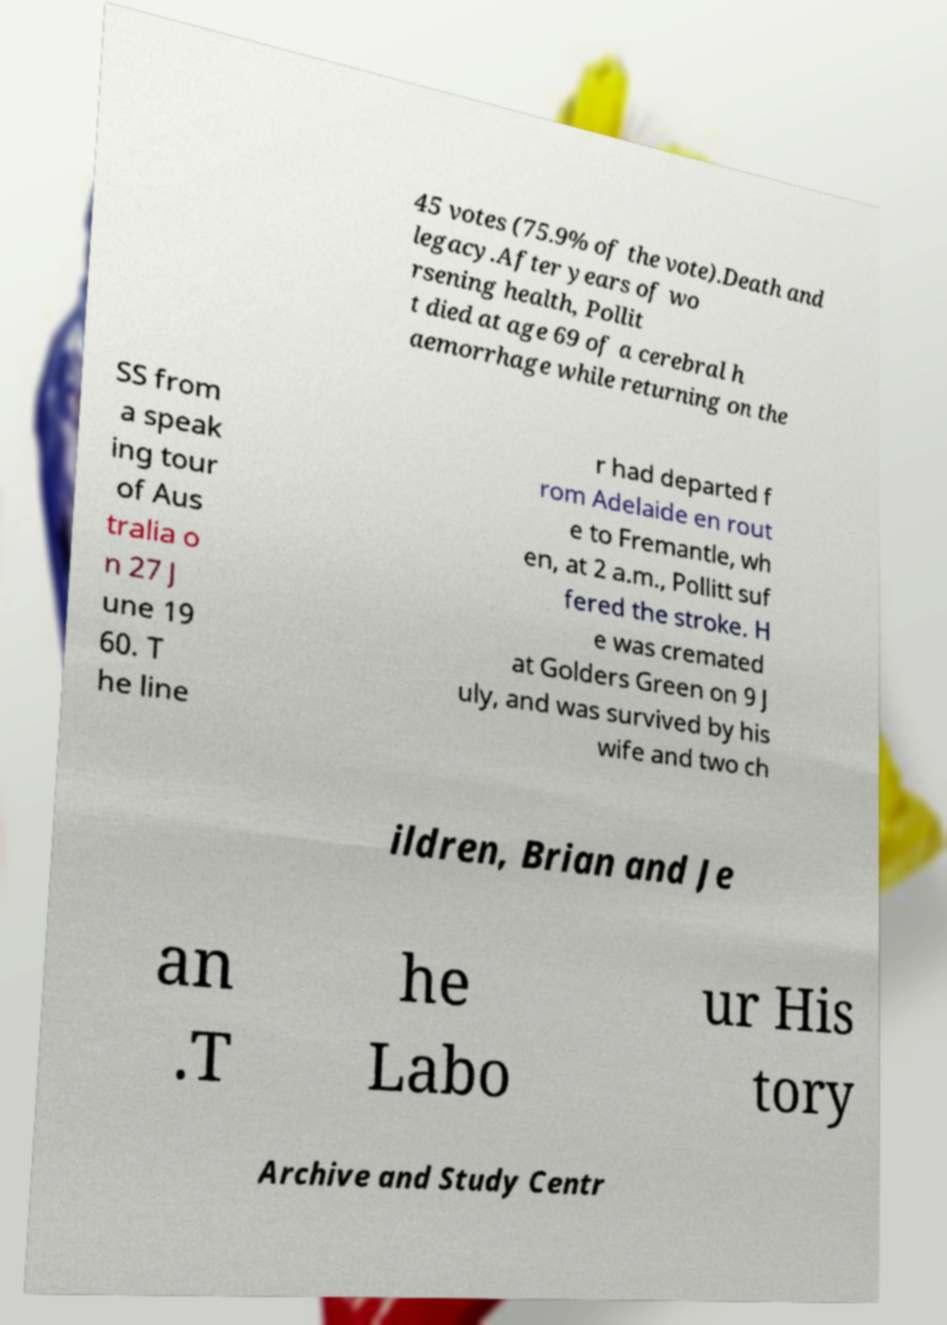Could you assist in decoding the text presented in this image and type it out clearly? 45 votes (75.9% of the vote).Death and legacy.After years of wo rsening health, Pollit t died at age 69 of a cerebral h aemorrhage while returning on the SS from a speak ing tour of Aus tralia o n 27 J une 19 60. T he line r had departed f rom Adelaide en rout e to Fremantle, wh en, at 2 a.m., Pollitt suf fered the stroke. H e was cremated at Golders Green on 9 J uly, and was survived by his wife and two ch ildren, Brian and Je an .T he Labo ur His tory Archive and Study Centr 